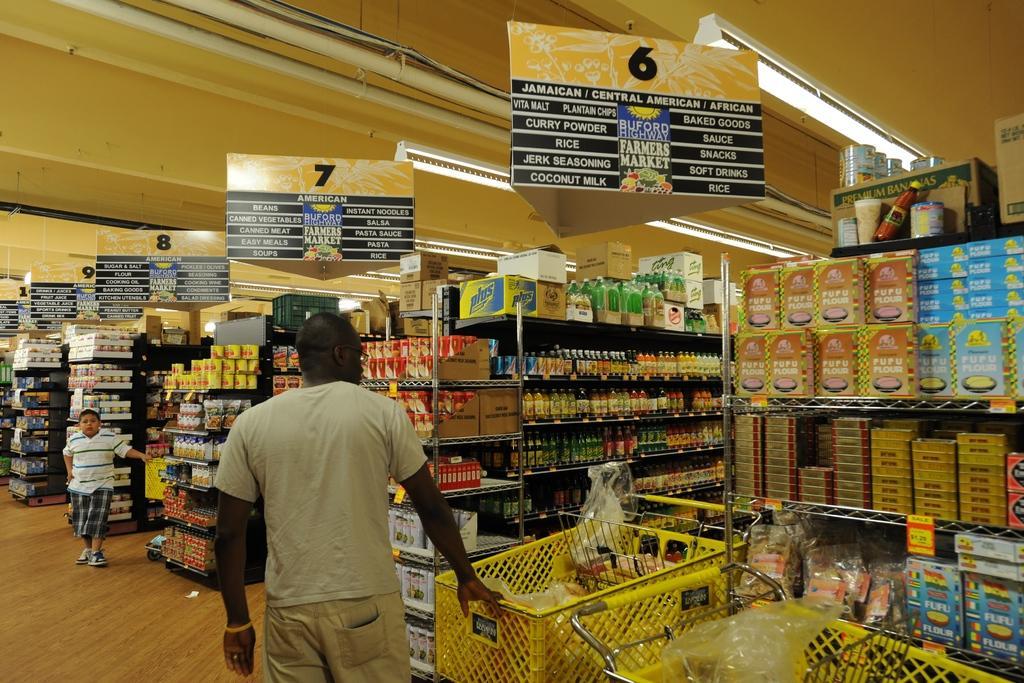Could you give a brief overview of what you see in this image? In this picture we can see there are two people standing on the path and a person is holding a cart. In front of the people there are some objects in the racks and at the top there are boards, lights and pipes. 